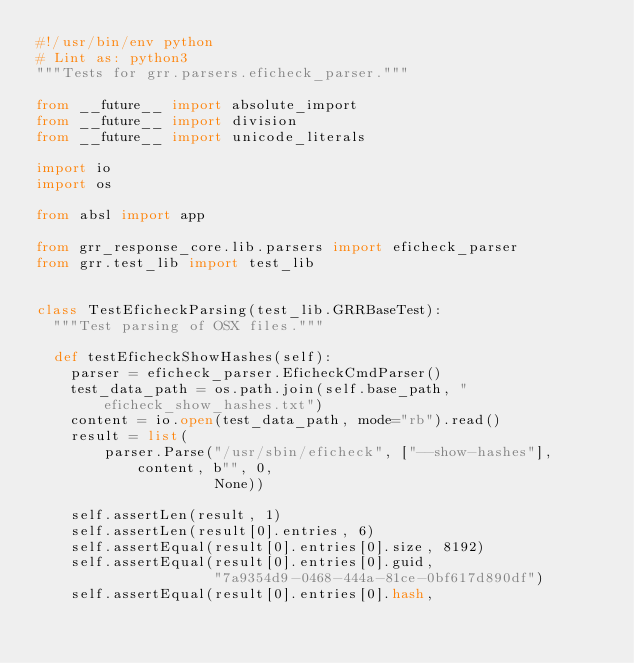<code> <loc_0><loc_0><loc_500><loc_500><_Python_>#!/usr/bin/env python
# Lint as: python3
"""Tests for grr.parsers.eficheck_parser."""

from __future__ import absolute_import
from __future__ import division
from __future__ import unicode_literals

import io
import os

from absl import app

from grr_response_core.lib.parsers import eficheck_parser
from grr.test_lib import test_lib


class TestEficheckParsing(test_lib.GRRBaseTest):
  """Test parsing of OSX files."""

  def testEficheckShowHashes(self):
    parser = eficheck_parser.EficheckCmdParser()
    test_data_path = os.path.join(self.base_path, "eficheck_show_hashes.txt")
    content = io.open(test_data_path, mode="rb").read()
    result = list(
        parser.Parse("/usr/sbin/eficheck", ["--show-hashes"], content, b"", 0,
                     None))

    self.assertLen(result, 1)
    self.assertLen(result[0].entries, 6)
    self.assertEqual(result[0].entries[0].size, 8192)
    self.assertEqual(result[0].entries[0].guid,
                     "7a9354d9-0468-444a-81ce-0bf617d890df")
    self.assertEqual(result[0].entries[0].hash,</code> 